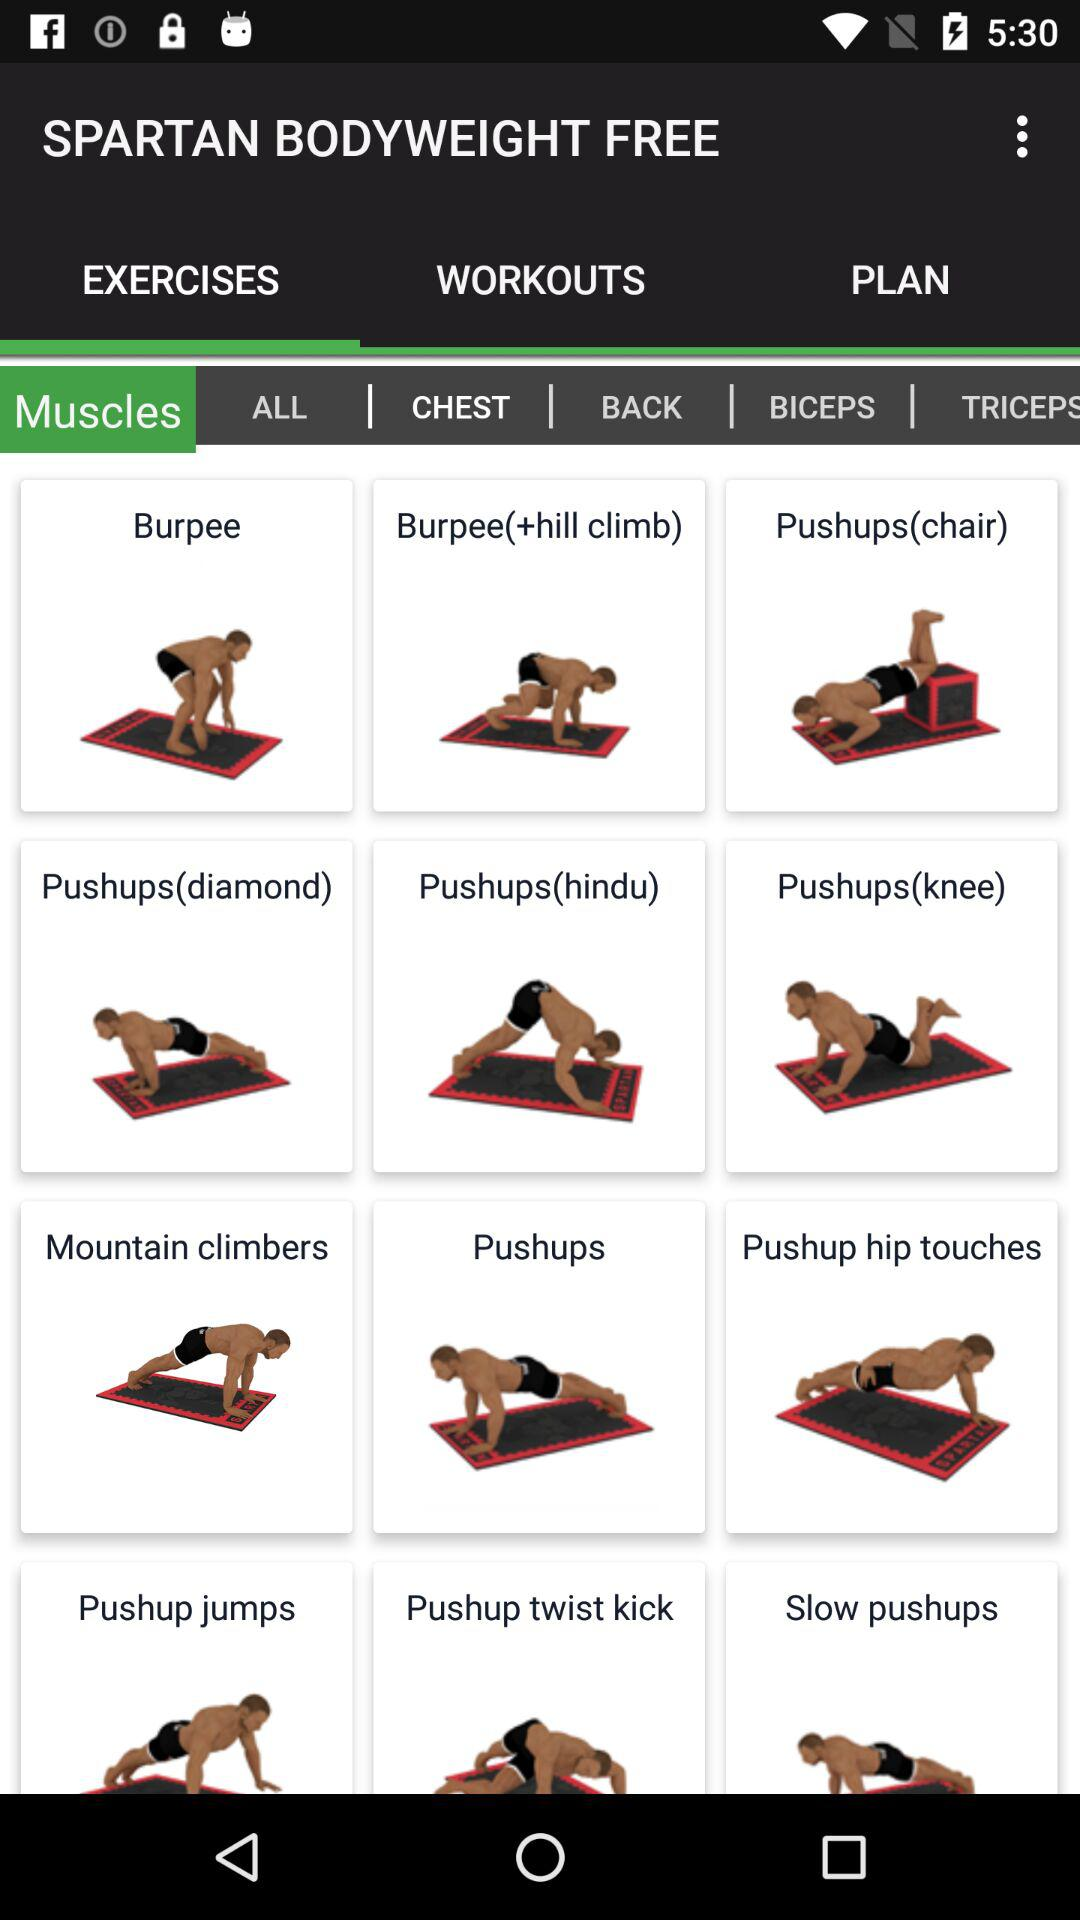Which body part is selected in "EXERCISES"? The selected body part is "CHEST". 